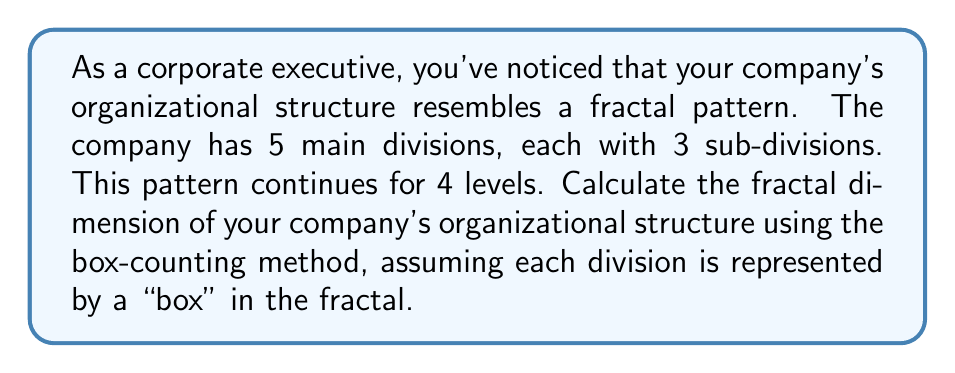Show me your answer to this math problem. To calculate the fractal dimension using the box-counting method, we'll follow these steps:

1. Identify the scaling factor (r):
   The scaling factor is the ratio between the sizes of boxes at each level.
   In this case, $r = \frac{1}{3}$ (each division splits into 3 sub-divisions)

2. Count the number of boxes (N) at each level:
   Level 0 (whole company): $N_0 = 1$
   Level 1 (main divisions): $N_1 = 5$
   Level 2 (sub-divisions): $N_2 = 5 \times 3 = 15$
   Level 3: $N_3 = 15 \times 3 = 45$
   Level 4: $N_4 = 45 \times 3 = 135$

3. Use the box-counting formula:
   $D = \frac{\log(N)}{\log(1/r)}$

   Where $N$ is the number of boxes at the final level (135) and $r$ is the scaling factor ($\frac{1}{3}$).

4. Plug in the values:
   $$D = \frac{\log(135)}{\log(3)} = \frac{\log(135)}{\log(3)} \approx 1.3746$$

The fractal dimension lies between 1 (a line) and 2 (a filled plane), indicating a complex, branching structure that's more than a simple hierarchy but less than a fully connected network.
Answer: $D \approx 1.3746$ 